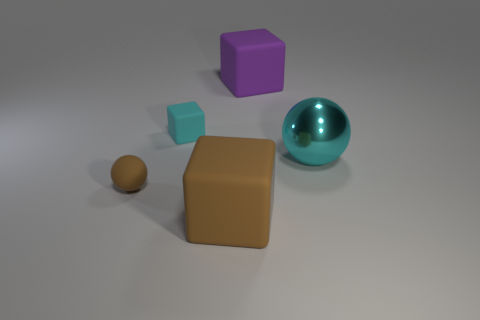Subtract 1 blocks. How many blocks are left? 2 Subtract all big purple cubes. How many cubes are left? 2 Add 4 spheres. How many objects exist? 9 Subtract all purple cubes. How many brown balls are left? 1 Subtract all small purple metal balls. Subtract all cyan spheres. How many objects are left? 4 Add 4 brown matte balls. How many brown matte balls are left? 5 Add 5 purple shiny cylinders. How many purple shiny cylinders exist? 5 Subtract all cyan spheres. How many spheres are left? 1 Subtract 0 red cylinders. How many objects are left? 5 Subtract all blocks. How many objects are left? 2 